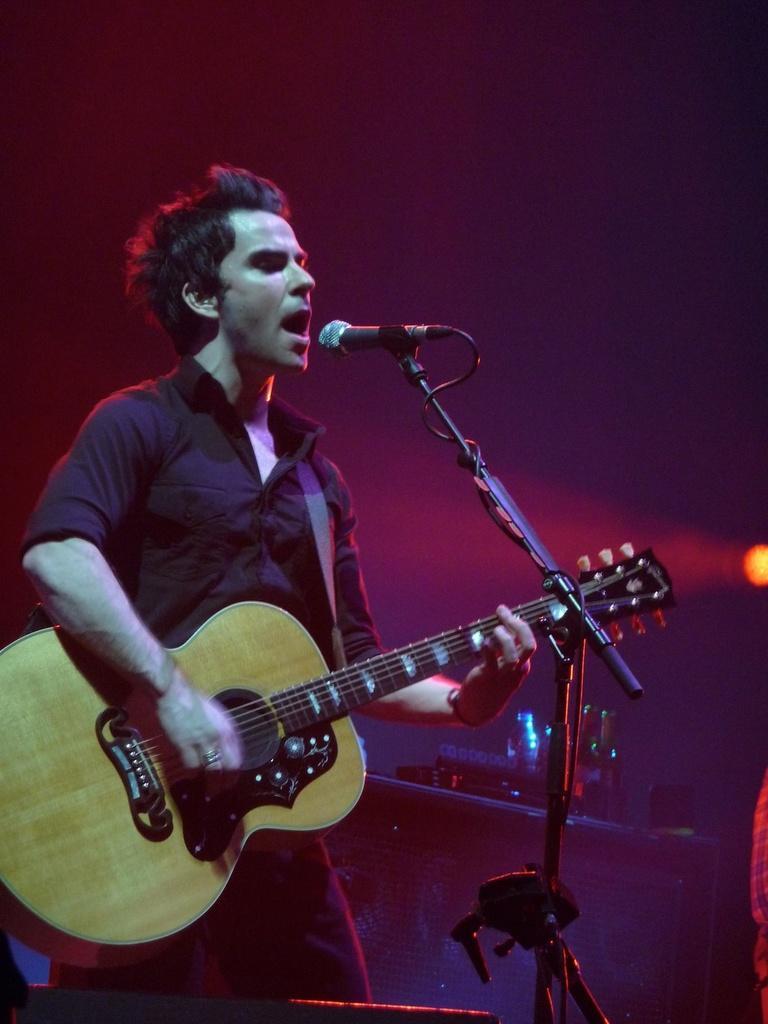Please provide a concise description of this image. In this image we have a man who is wearing a black shirt and playing guitar in his hands in front of the microphone and singing a song. 